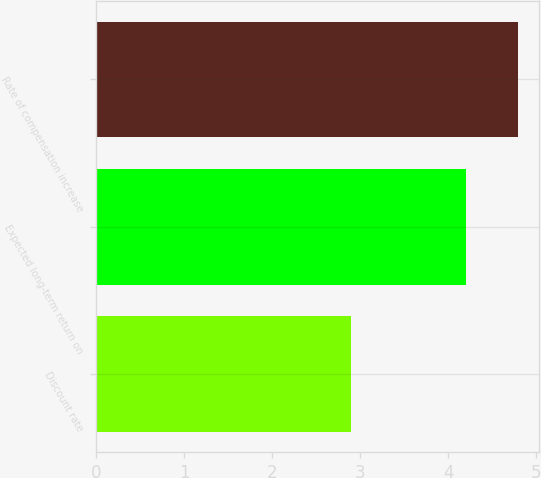<chart> <loc_0><loc_0><loc_500><loc_500><bar_chart><fcel>Discount rate<fcel>Expected long-term return on<fcel>Rate of compensation increase<nl><fcel>2.9<fcel>4.2<fcel>4.8<nl></chart> 